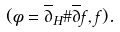<formula> <loc_0><loc_0><loc_500><loc_500>( \phi = \overline { \partial } _ { H } \# \overline { \partial } f , f ) .</formula> 